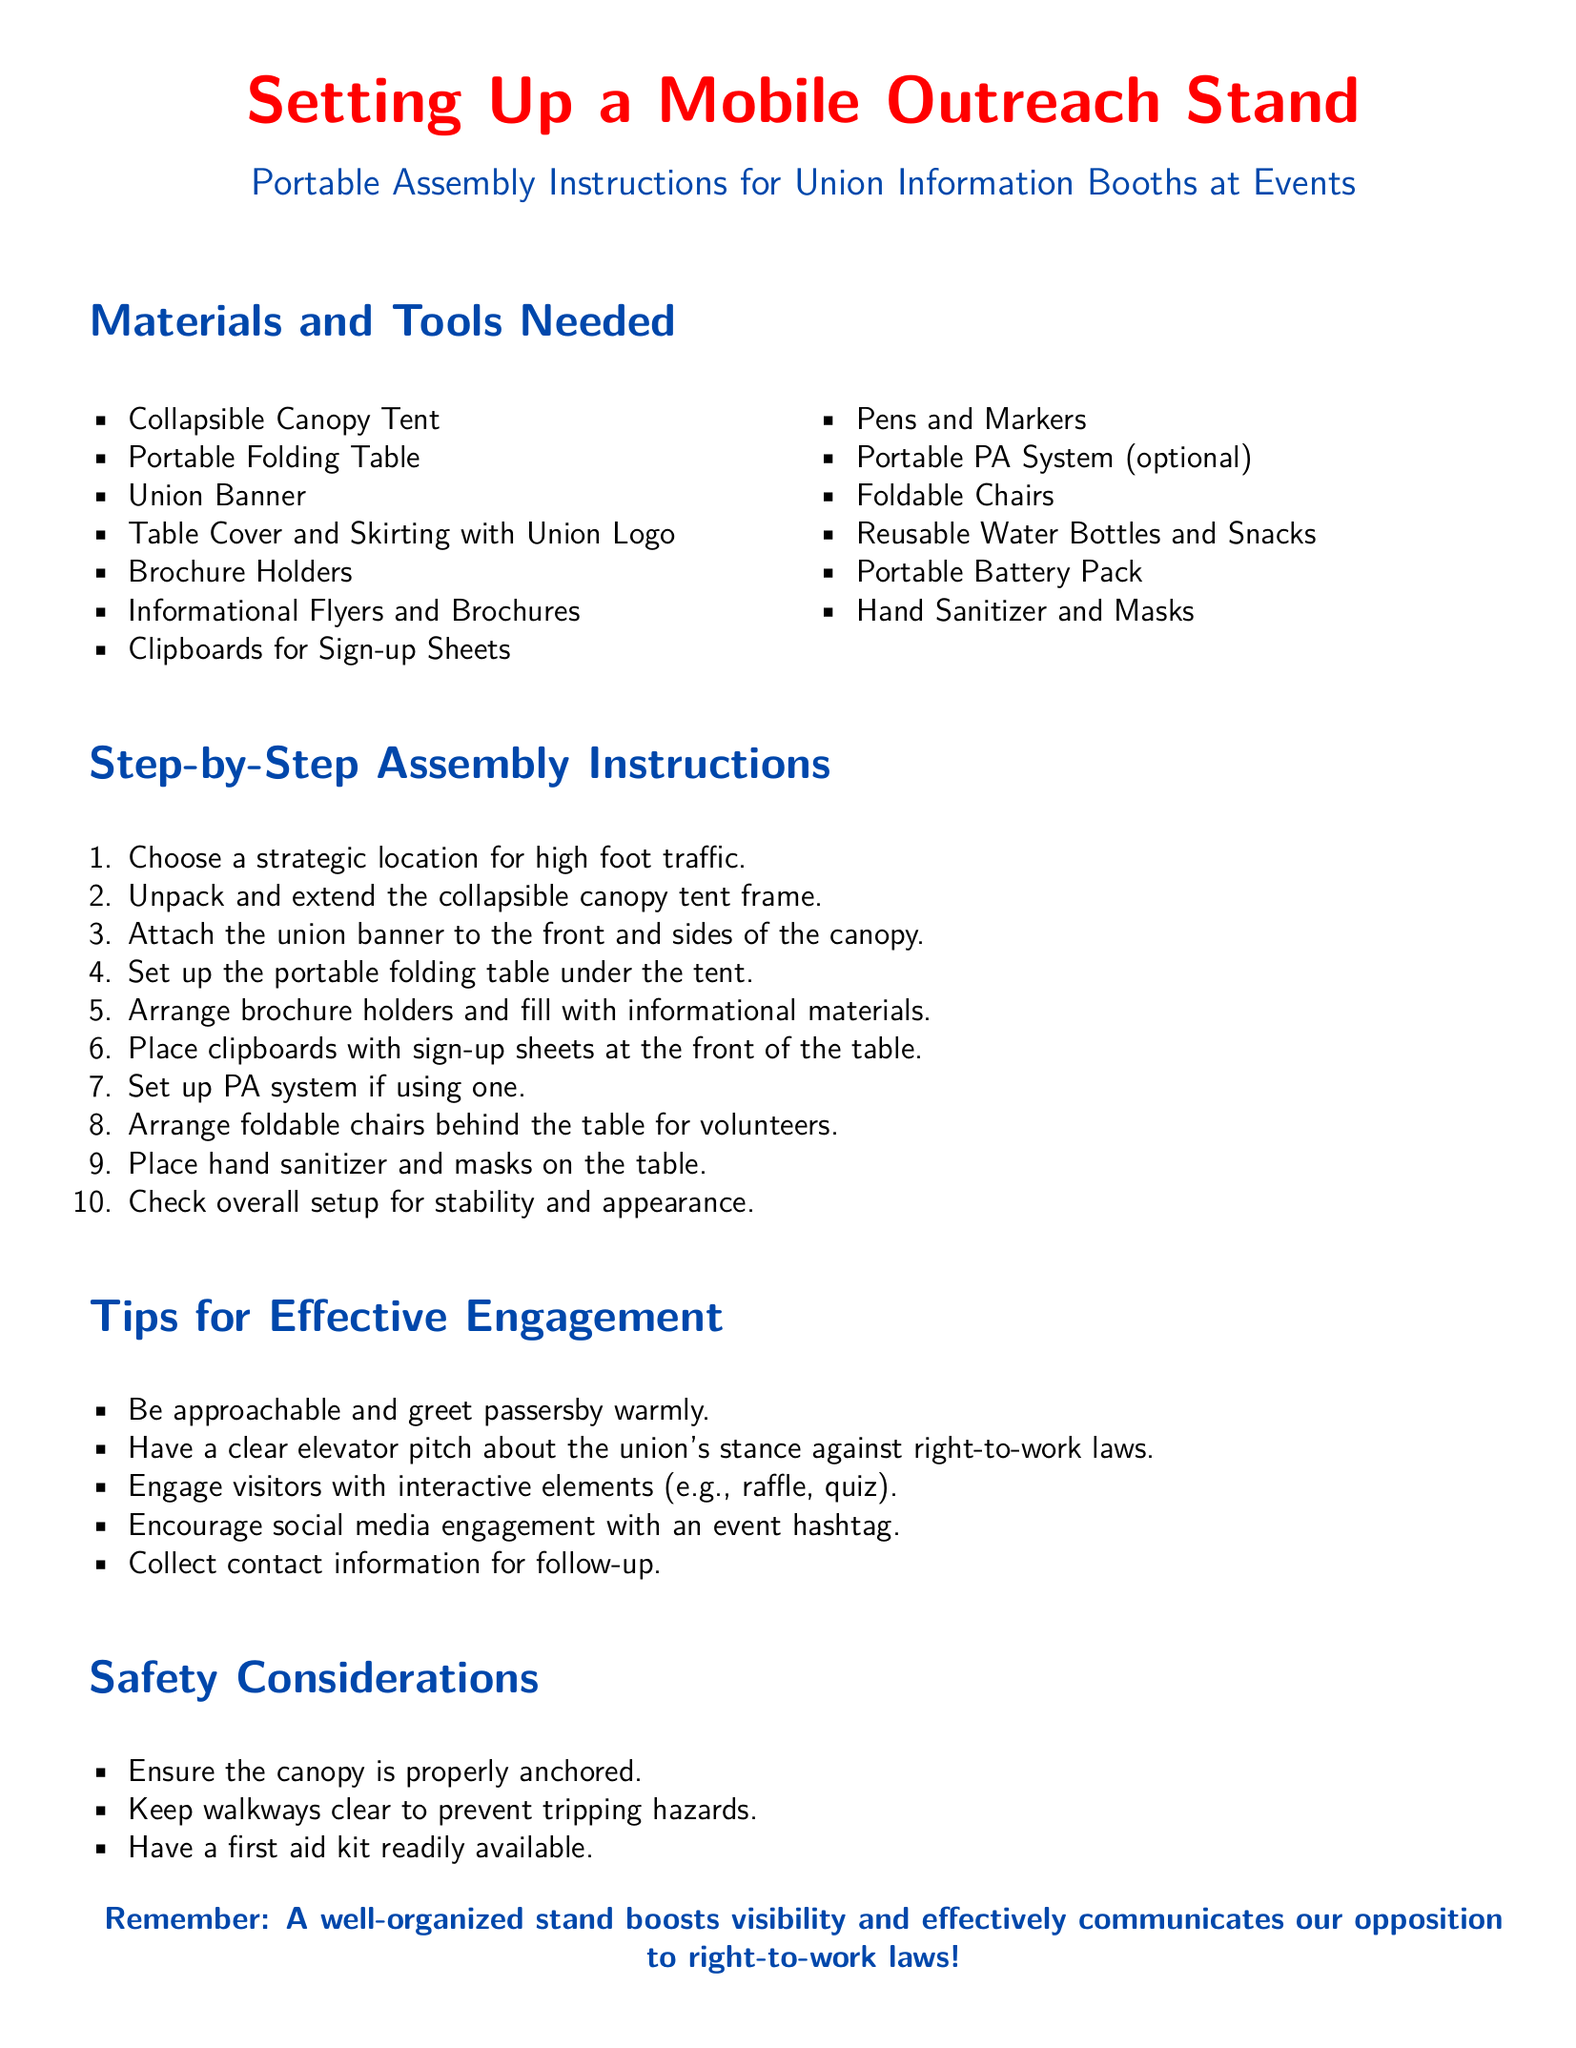What is the title of the document? The title appears at the top of the document, prominently displayed as "Setting Up a Mobile Outreach Stand."
Answer: Setting Up a Mobile Outreach Stand How many materials are listed in the "Materials and Tools Needed" section? The list consists of items under "Materials and Tools Needed," which are counted to determine the total.
Answer: 12 What color is the union banner mentioned in the instructions? The color of the union banner is not specified explicitly, but it is typically associated with union-related colors in the context of this document.
Answer: Not specified What is one item that can be set up for volunteers behind the table? The document details the setup and includes specific items placed for volunteers behind the table.
Answer: Foldable Chairs What should be checked before finalizing the setup? The assembly instructions suggest ensuring certain elements are in place before completing the setup process.
Answer: Stability and appearance What is mentioned as an optional item in the materials? The materials section lists items, some of which are optional, specifically denoting one of them.
Answer: Portable PA System What action is recommended to engage visitors? The document includes a section with tips specifically suggesting actions for effective engagement with visitors.
Answer: Interactive elements How should the canopy be secured? The safety considerations section provides guidelines on how to ensure the setup is safe and stable during the event.
Answer: Properly anchored 